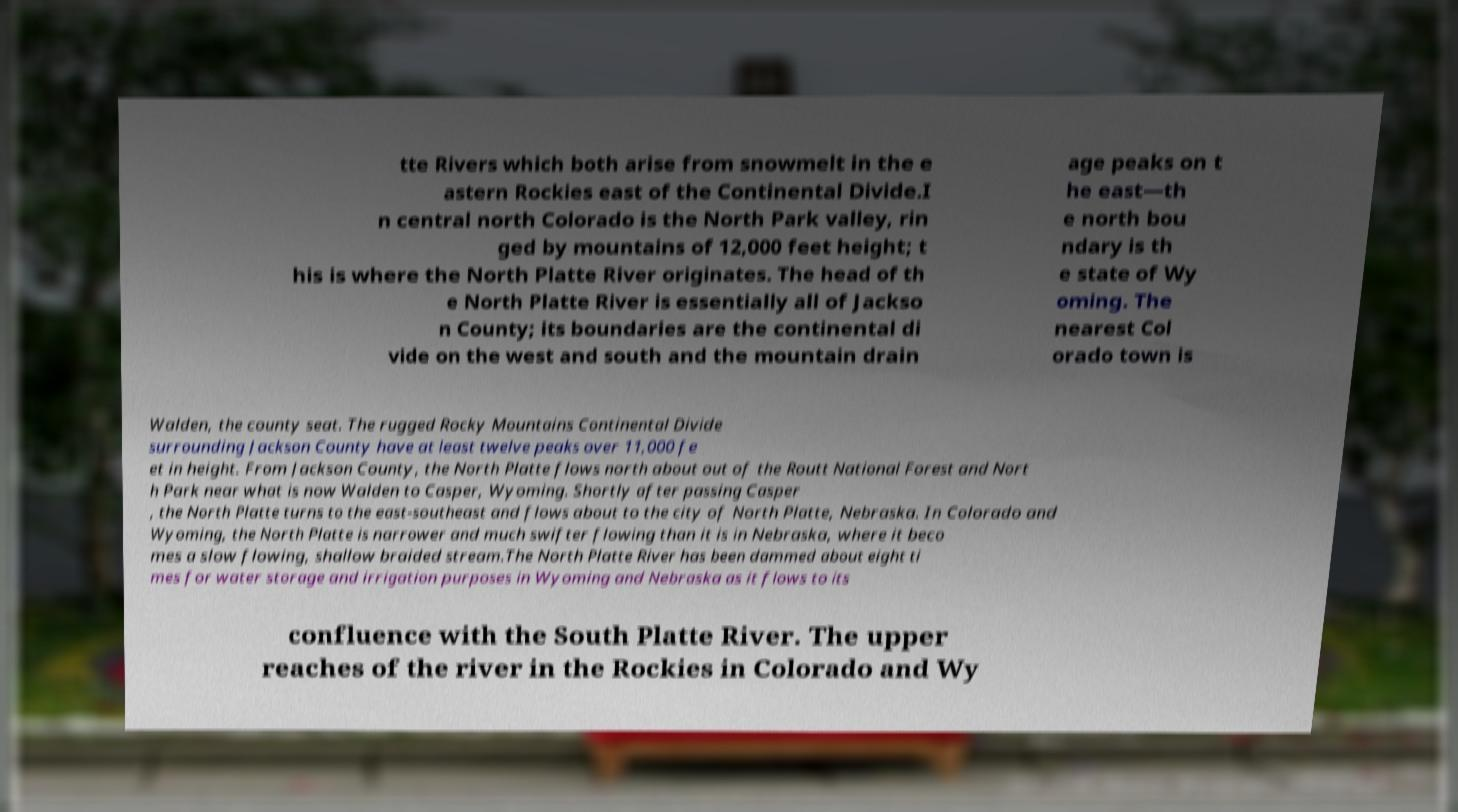Can you read and provide the text displayed in the image?This photo seems to have some interesting text. Can you extract and type it out for me? tte Rivers which both arise from snowmelt in the e astern Rockies east of the Continental Divide.I n central north Colorado is the North Park valley, rin ged by mountains of 12,000 feet height; t his is where the North Platte River originates. The head of th e North Platte River is essentially all of Jackso n County; its boundaries are the continental di vide on the west and south and the mountain drain age peaks on t he east—th e north bou ndary is th e state of Wy oming. The nearest Col orado town is Walden, the county seat. The rugged Rocky Mountains Continental Divide surrounding Jackson County have at least twelve peaks over 11,000 fe et in height. From Jackson County, the North Platte flows north about out of the Routt National Forest and Nort h Park near what is now Walden to Casper, Wyoming. Shortly after passing Casper , the North Platte turns to the east-southeast and flows about to the city of North Platte, Nebraska. In Colorado and Wyoming, the North Platte is narrower and much swifter flowing than it is in Nebraska, where it beco mes a slow flowing, shallow braided stream.The North Platte River has been dammed about eight ti mes for water storage and irrigation purposes in Wyoming and Nebraska as it flows to its confluence with the South Platte River. The upper reaches of the river in the Rockies in Colorado and Wy 